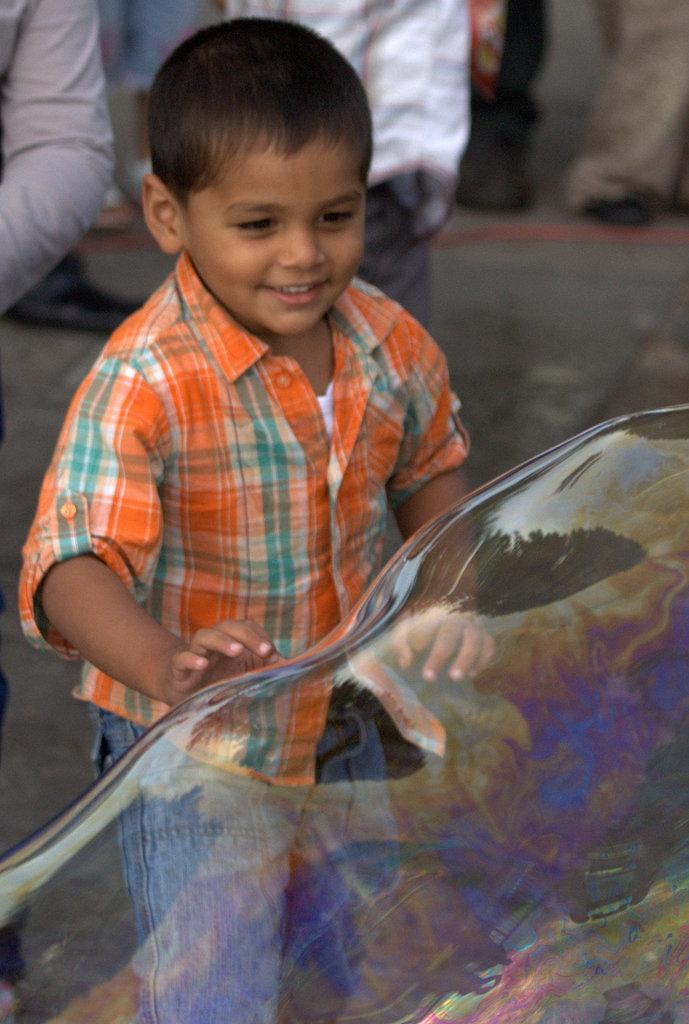Who is the main subject in the image? A: There is a boy in the image. What is the boy wearing? The boy is wearing a shirt. What is the boy doing in the image? The boy is standing. What else can be seen in the image besides the boy? There is a soap bubble in the image. What can be seen in the background of the image? There are people in the background of the image, and they are on a path. What type of system is the boy using to create the soap bubble in the image? There is no system visible in the image for creating the soap bubble; it is simply present. How does the baby contribute to the image? There is no baby present in the image. 